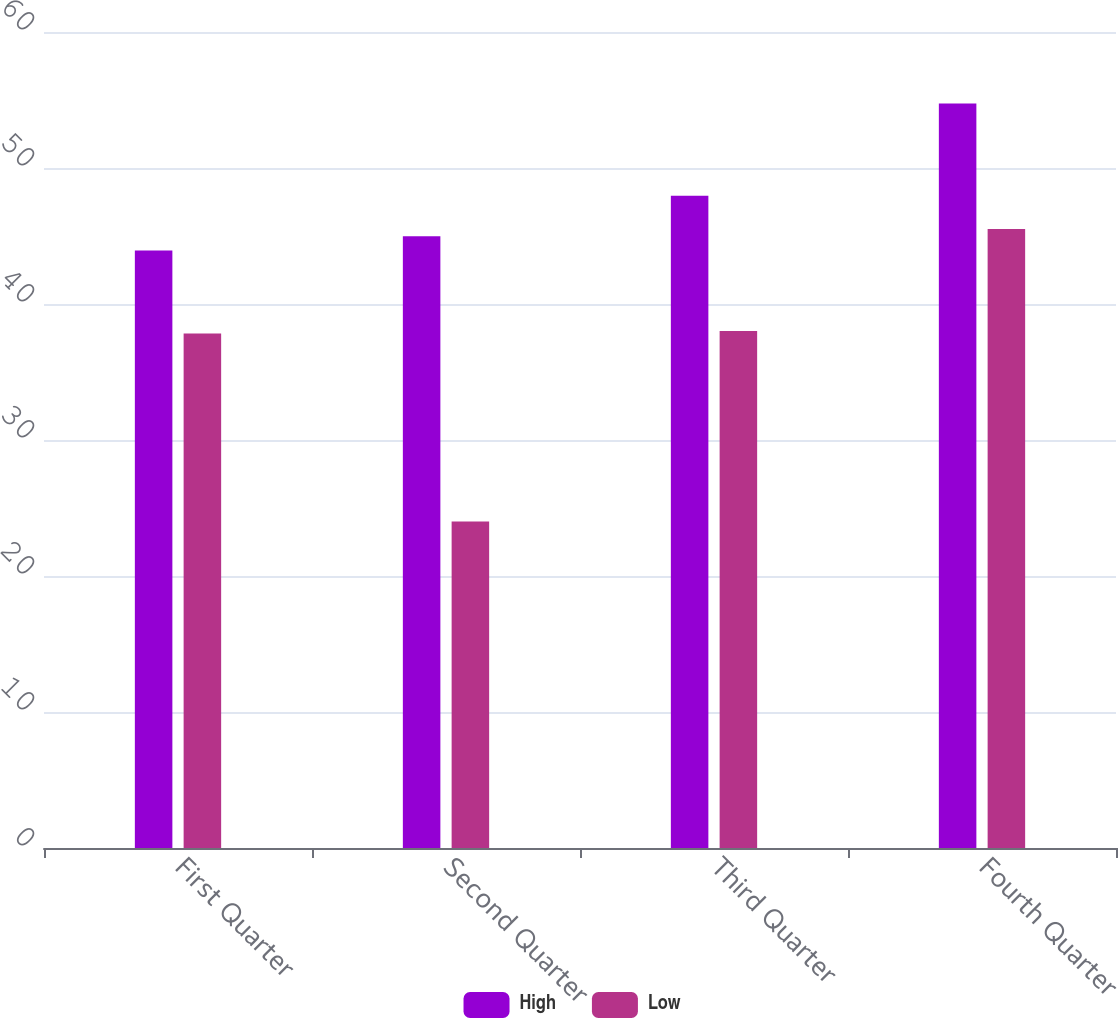Convert chart. <chart><loc_0><loc_0><loc_500><loc_500><stacked_bar_chart><ecel><fcel>First Quarter<fcel>Second Quarter<fcel>Third Quarter<fcel>Fourth Quarter<nl><fcel>High<fcel>43.94<fcel>44.99<fcel>47.96<fcel>54.75<nl><fcel>Low<fcel>37.83<fcel>24.01<fcel>38.02<fcel>45.51<nl></chart> 